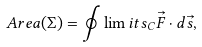Convert formula to latex. <formula><loc_0><loc_0><loc_500><loc_500>A r e a ( \Sigma ) = \oint \lim i t s _ { C } \vec { F } \cdot d \vec { s } ,</formula> 